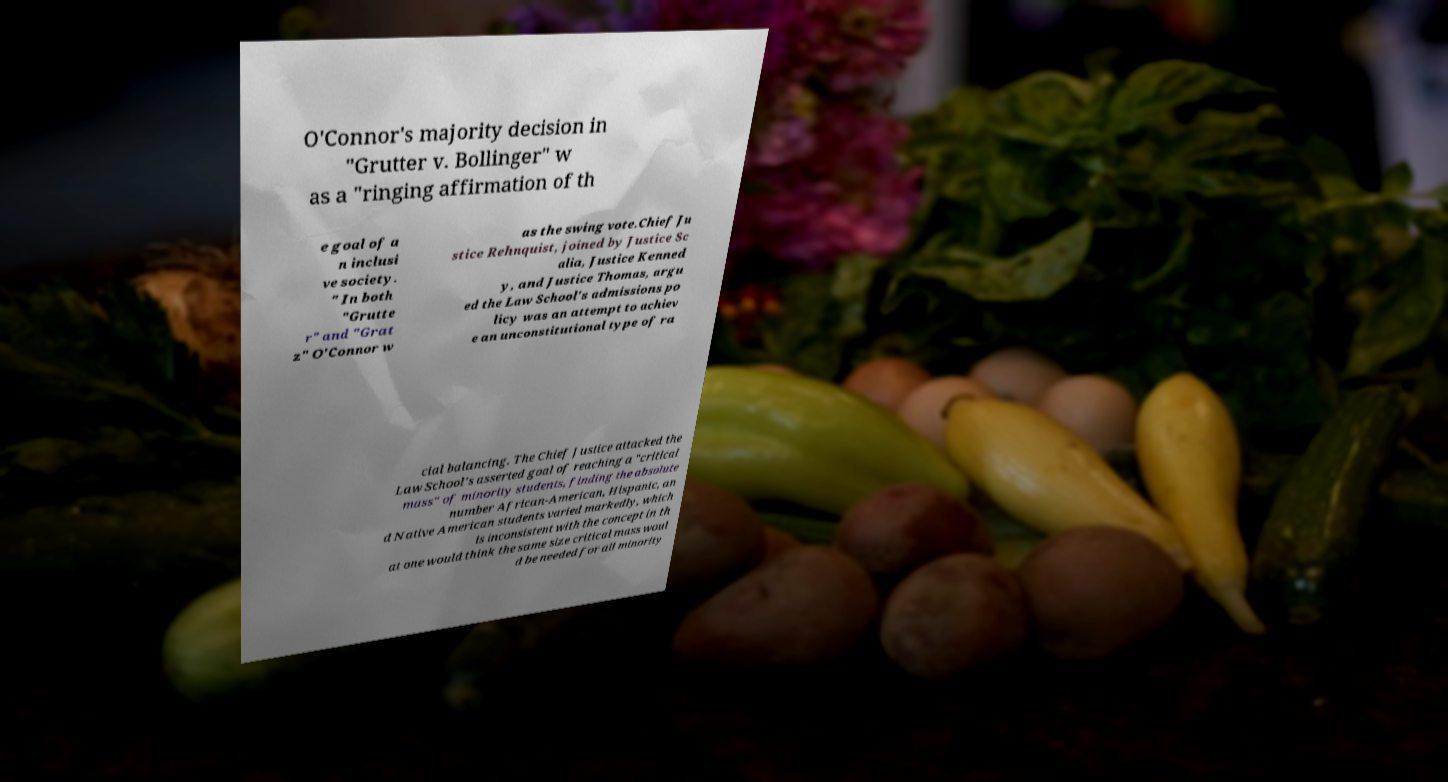Could you extract and type out the text from this image? O'Connor's majority decision in "Grutter v. Bollinger" w as a "ringing affirmation of th e goal of a n inclusi ve society. " In both "Grutte r" and "Grat z" O'Connor w as the swing vote.Chief Ju stice Rehnquist, joined by Justice Sc alia, Justice Kenned y, and Justice Thomas, argu ed the Law School's admissions po licy was an attempt to achiev e an unconstitutional type of ra cial balancing. The Chief Justice attacked the Law School's asserted goal of reaching a "critical mass" of minority students, finding the absolute number African-American, Hispanic, an d Native American students varied markedly, which is inconsistent with the concept in th at one would think the same size critical mass woul d be needed for all minority 